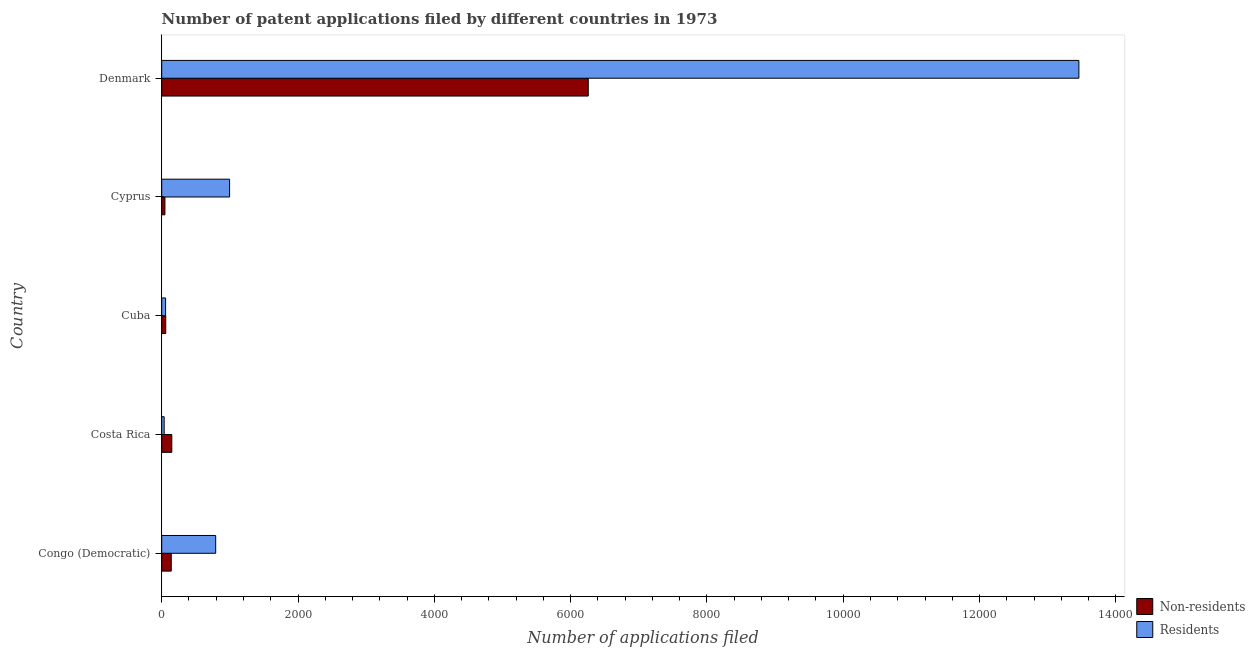How many groups of bars are there?
Make the answer very short. 5. Are the number of bars on each tick of the Y-axis equal?
Provide a succinct answer. Yes. How many bars are there on the 5th tick from the top?
Provide a succinct answer. 2. What is the number of patent applications by residents in Cyprus?
Offer a terse response. 996. Across all countries, what is the maximum number of patent applications by non residents?
Provide a succinct answer. 6259. Across all countries, what is the minimum number of patent applications by residents?
Your response must be concise. 36. In which country was the number of patent applications by non residents minimum?
Offer a very short reply. Cyprus. What is the total number of patent applications by non residents in the graph?
Give a very brief answer. 6653. What is the difference between the number of patent applications by non residents in Costa Rica and that in Cuba?
Keep it short and to the point. 89. What is the difference between the number of patent applications by residents in Costa Rica and the number of patent applications by non residents in Cyprus?
Provide a succinct answer. -11. What is the average number of patent applications by non residents per country?
Your answer should be compact. 1330.6. What is the difference between the number of patent applications by residents and number of patent applications by non residents in Cuba?
Offer a very short reply. -2. What is the ratio of the number of patent applications by non residents in Congo (Democratic) to that in Cyprus?
Your response must be concise. 2.98. Is the number of patent applications by non residents in Congo (Democratic) less than that in Cuba?
Give a very brief answer. No. Is the difference between the number of patent applications by residents in Congo (Democratic) and Costa Rica greater than the difference between the number of patent applications by non residents in Congo (Democratic) and Costa Rica?
Make the answer very short. Yes. What is the difference between the highest and the second highest number of patent applications by residents?
Keep it short and to the point. 1.25e+04. What is the difference between the highest and the lowest number of patent applications by non residents?
Your answer should be compact. 6212. Is the sum of the number of patent applications by residents in Costa Rica and Denmark greater than the maximum number of patent applications by non residents across all countries?
Keep it short and to the point. Yes. What does the 1st bar from the top in Costa Rica represents?
Provide a short and direct response. Residents. What does the 2nd bar from the bottom in Cuba represents?
Offer a very short reply. Residents. How many bars are there?
Make the answer very short. 10. How many countries are there in the graph?
Your answer should be compact. 5. What is the difference between two consecutive major ticks on the X-axis?
Provide a short and direct response. 2000. Are the values on the major ticks of X-axis written in scientific E-notation?
Offer a terse response. No. Does the graph contain any zero values?
Your answer should be compact. No. Does the graph contain grids?
Your response must be concise. No. Where does the legend appear in the graph?
Make the answer very short. Bottom right. What is the title of the graph?
Your answer should be very brief. Number of patent applications filed by different countries in 1973. Does "Investment in Transport" appear as one of the legend labels in the graph?
Offer a very short reply. No. What is the label or title of the X-axis?
Your response must be concise. Number of applications filed. What is the label or title of the Y-axis?
Ensure brevity in your answer.  Country. What is the Number of applications filed in Non-residents in Congo (Democratic)?
Make the answer very short. 140. What is the Number of applications filed in Residents in Congo (Democratic)?
Your response must be concise. 792. What is the Number of applications filed in Non-residents in Costa Rica?
Provide a short and direct response. 148. What is the Number of applications filed in Residents in Cyprus?
Provide a short and direct response. 996. What is the Number of applications filed in Non-residents in Denmark?
Your answer should be compact. 6259. What is the Number of applications filed of Residents in Denmark?
Your answer should be very brief. 1.35e+04. Across all countries, what is the maximum Number of applications filed in Non-residents?
Your response must be concise. 6259. Across all countries, what is the maximum Number of applications filed of Residents?
Ensure brevity in your answer.  1.35e+04. What is the total Number of applications filed in Non-residents in the graph?
Provide a short and direct response. 6653. What is the total Number of applications filed in Residents in the graph?
Provide a short and direct response. 1.53e+04. What is the difference between the Number of applications filed of Non-residents in Congo (Democratic) and that in Costa Rica?
Make the answer very short. -8. What is the difference between the Number of applications filed of Residents in Congo (Democratic) and that in Costa Rica?
Offer a very short reply. 756. What is the difference between the Number of applications filed in Residents in Congo (Democratic) and that in Cuba?
Ensure brevity in your answer.  735. What is the difference between the Number of applications filed of Non-residents in Congo (Democratic) and that in Cyprus?
Offer a terse response. 93. What is the difference between the Number of applications filed in Residents in Congo (Democratic) and that in Cyprus?
Ensure brevity in your answer.  -204. What is the difference between the Number of applications filed in Non-residents in Congo (Democratic) and that in Denmark?
Provide a short and direct response. -6119. What is the difference between the Number of applications filed of Residents in Congo (Democratic) and that in Denmark?
Ensure brevity in your answer.  -1.27e+04. What is the difference between the Number of applications filed of Non-residents in Costa Rica and that in Cuba?
Give a very brief answer. 89. What is the difference between the Number of applications filed of Residents in Costa Rica and that in Cuba?
Ensure brevity in your answer.  -21. What is the difference between the Number of applications filed of Non-residents in Costa Rica and that in Cyprus?
Offer a very short reply. 101. What is the difference between the Number of applications filed of Residents in Costa Rica and that in Cyprus?
Offer a very short reply. -960. What is the difference between the Number of applications filed in Non-residents in Costa Rica and that in Denmark?
Your response must be concise. -6111. What is the difference between the Number of applications filed in Residents in Costa Rica and that in Denmark?
Give a very brief answer. -1.34e+04. What is the difference between the Number of applications filed in Residents in Cuba and that in Cyprus?
Provide a short and direct response. -939. What is the difference between the Number of applications filed in Non-residents in Cuba and that in Denmark?
Your answer should be compact. -6200. What is the difference between the Number of applications filed of Residents in Cuba and that in Denmark?
Make the answer very short. -1.34e+04. What is the difference between the Number of applications filed of Non-residents in Cyprus and that in Denmark?
Give a very brief answer. -6212. What is the difference between the Number of applications filed in Residents in Cyprus and that in Denmark?
Offer a very short reply. -1.25e+04. What is the difference between the Number of applications filed of Non-residents in Congo (Democratic) and the Number of applications filed of Residents in Costa Rica?
Your response must be concise. 104. What is the difference between the Number of applications filed of Non-residents in Congo (Democratic) and the Number of applications filed of Residents in Cuba?
Provide a succinct answer. 83. What is the difference between the Number of applications filed of Non-residents in Congo (Democratic) and the Number of applications filed of Residents in Cyprus?
Provide a succinct answer. -856. What is the difference between the Number of applications filed of Non-residents in Congo (Democratic) and the Number of applications filed of Residents in Denmark?
Make the answer very short. -1.33e+04. What is the difference between the Number of applications filed in Non-residents in Costa Rica and the Number of applications filed in Residents in Cuba?
Your answer should be very brief. 91. What is the difference between the Number of applications filed of Non-residents in Costa Rica and the Number of applications filed of Residents in Cyprus?
Your answer should be compact. -848. What is the difference between the Number of applications filed in Non-residents in Costa Rica and the Number of applications filed in Residents in Denmark?
Your answer should be compact. -1.33e+04. What is the difference between the Number of applications filed in Non-residents in Cuba and the Number of applications filed in Residents in Cyprus?
Ensure brevity in your answer.  -937. What is the difference between the Number of applications filed in Non-residents in Cuba and the Number of applications filed in Residents in Denmark?
Give a very brief answer. -1.34e+04. What is the difference between the Number of applications filed in Non-residents in Cyprus and the Number of applications filed in Residents in Denmark?
Give a very brief answer. -1.34e+04. What is the average Number of applications filed of Non-residents per country?
Your response must be concise. 1330.6. What is the average Number of applications filed of Residents per country?
Your answer should be compact. 3067.8. What is the difference between the Number of applications filed in Non-residents and Number of applications filed in Residents in Congo (Democratic)?
Ensure brevity in your answer.  -652. What is the difference between the Number of applications filed of Non-residents and Number of applications filed of Residents in Costa Rica?
Keep it short and to the point. 112. What is the difference between the Number of applications filed in Non-residents and Number of applications filed in Residents in Cuba?
Your response must be concise. 2. What is the difference between the Number of applications filed of Non-residents and Number of applications filed of Residents in Cyprus?
Keep it short and to the point. -949. What is the difference between the Number of applications filed of Non-residents and Number of applications filed of Residents in Denmark?
Ensure brevity in your answer.  -7199. What is the ratio of the Number of applications filed of Non-residents in Congo (Democratic) to that in Costa Rica?
Give a very brief answer. 0.95. What is the ratio of the Number of applications filed in Residents in Congo (Democratic) to that in Costa Rica?
Make the answer very short. 22. What is the ratio of the Number of applications filed of Non-residents in Congo (Democratic) to that in Cuba?
Keep it short and to the point. 2.37. What is the ratio of the Number of applications filed in Residents in Congo (Democratic) to that in Cuba?
Your answer should be compact. 13.89. What is the ratio of the Number of applications filed in Non-residents in Congo (Democratic) to that in Cyprus?
Your answer should be very brief. 2.98. What is the ratio of the Number of applications filed in Residents in Congo (Democratic) to that in Cyprus?
Your answer should be compact. 0.8. What is the ratio of the Number of applications filed in Non-residents in Congo (Democratic) to that in Denmark?
Offer a terse response. 0.02. What is the ratio of the Number of applications filed in Residents in Congo (Democratic) to that in Denmark?
Provide a succinct answer. 0.06. What is the ratio of the Number of applications filed of Non-residents in Costa Rica to that in Cuba?
Provide a short and direct response. 2.51. What is the ratio of the Number of applications filed of Residents in Costa Rica to that in Cuba?
Your response must be concise. 0.63. What is the ratio of the Number of applications filed of Non-residents in Costa Rica to that in Cyprus?
Provide a succinct answer. 3.15. What is the ratio of the Number of applications filed in Residents in Costa Rica to that in Cyprus?
Provide a short and direct response. 0.04. What is the ratio of the Number of applications filed in Non-residents in Costa Rica to that in Denmark?
Provide a short and direct response. 0.02. What is the ratio of the Number of applications filed in Residents in Costa Rica to that in Denmark?
Ensure brevity in your answer.  0. What is the ratio of the Number of applications filed of Non-residents in Cuba to that in Cyprus?
Offer a very short reply. 1.26. What is the ratio of the Number of applications filed in Residents in Cuba to that in Cyprus?
Ensure brevity in your answer.  0.06. What is the ratio of the Number of applications filed of Non-residents in Cuba to that in Denmark?
Your answer should be very brief. 0.01. What is the ratio of the Number of applications filed of Residents in Cuba to that in Denmark?
Ensure brevity in your answer.  0. What is the ratio of the Number of applications filed in Non-residents in Cyprus to that in Denmark?
Your answer should be very brief. 0.01. What is the ratio of the Number of applications filed of Residents in Cyprus to that in Denmark?
Make the answer very short. 0.07. What is the difference between the highest and the second highest Number of applications filed in Non-residents?
Offer a very short reply. 6111. What is the difference between the highest and the second highest Number of applications filed of Residents?
Provide a short and direct response. 1.25e+04. What is the difference between the highest and the lowest Number of applications filed in Non-residents?
Offer a terse response. 6212. What is the difference between the highest and the lowest Number of applications filed in Residents?
Your answer should be compact. 1.34e+04. 